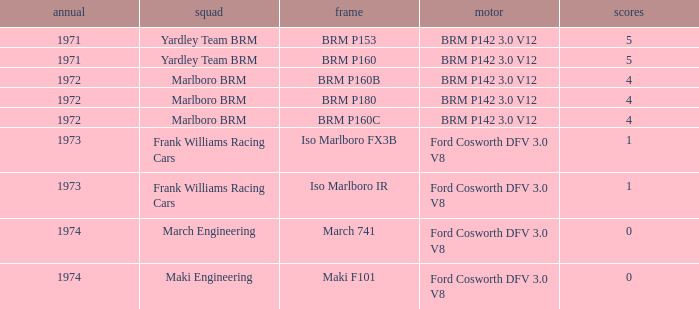Which chassis has marlboro brm as the team? BRM P160B, BRM P180, BRM P160C. 